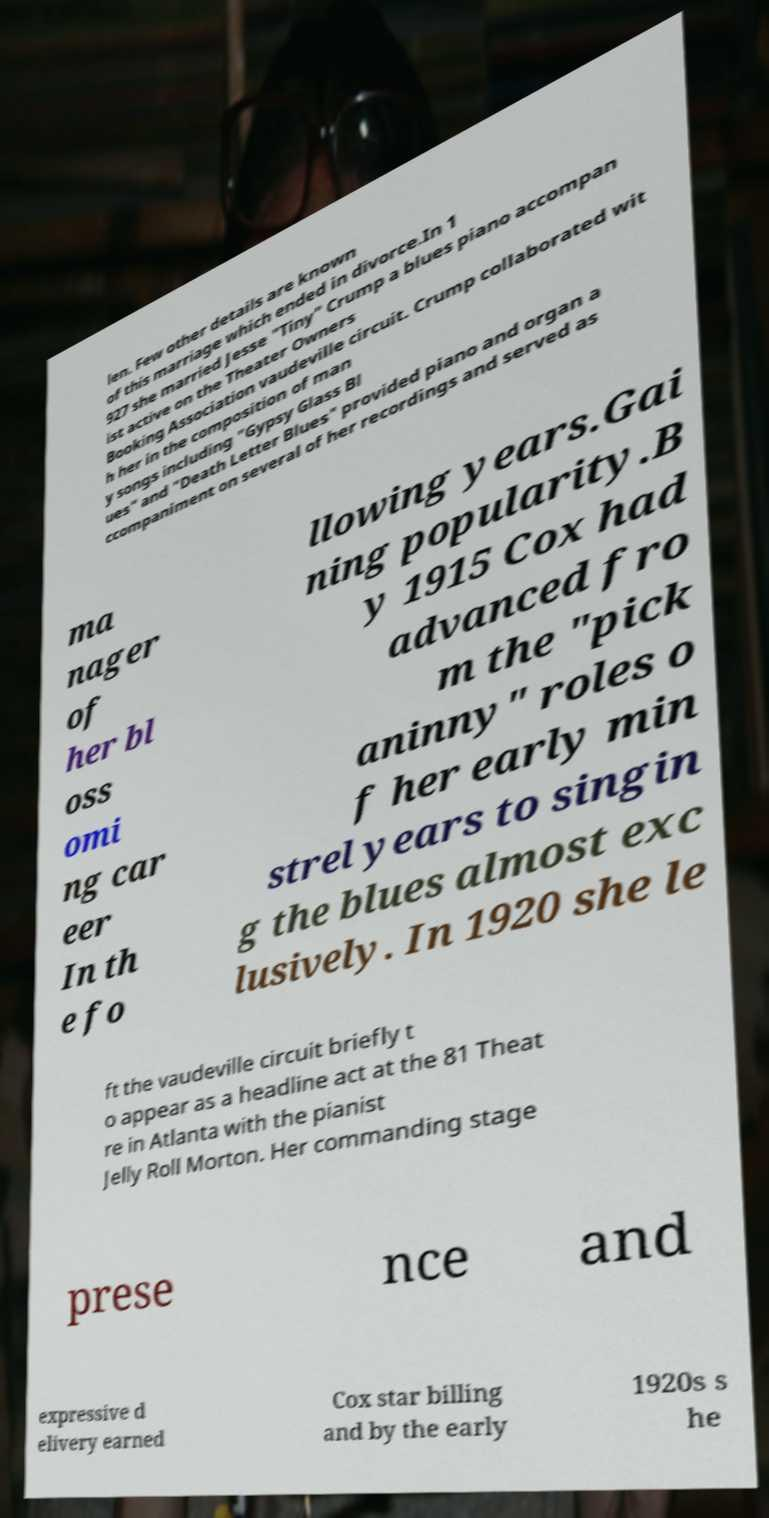What messages or text are displayed in this image? I need them in a readable, typed format. len. Few other details are known of this marriage which ended in divorce.In 1 927 she married Jesse "Tiny" Crump a blues piano accompan ist active on the Theater Owners Booking Association vaudeville circuit. Crump collaborated wit h her in the composition of man y songs including "Gypsy Glass Bl ues" and "Death Letter Blues" provided piano and organ a ccompaniment on several of her recordings and served as ma nager of her bl oss omi ng car eer In th e fo llowing years.Gai ning popularity.B y 1915 Cox had advanced fro m the "pick aninny" roles o f her early min strel years to singin g the blues almost exc lusively. In 1920 she le ft the vaudeville circuit briefly t o appear as a headline act at the 81 Theat re in Atlanta with the pianist Jelly Roll Morton. Her commanding stage prese nce and expressive d elivery earned Cox star billing and by the early 1920s s he 